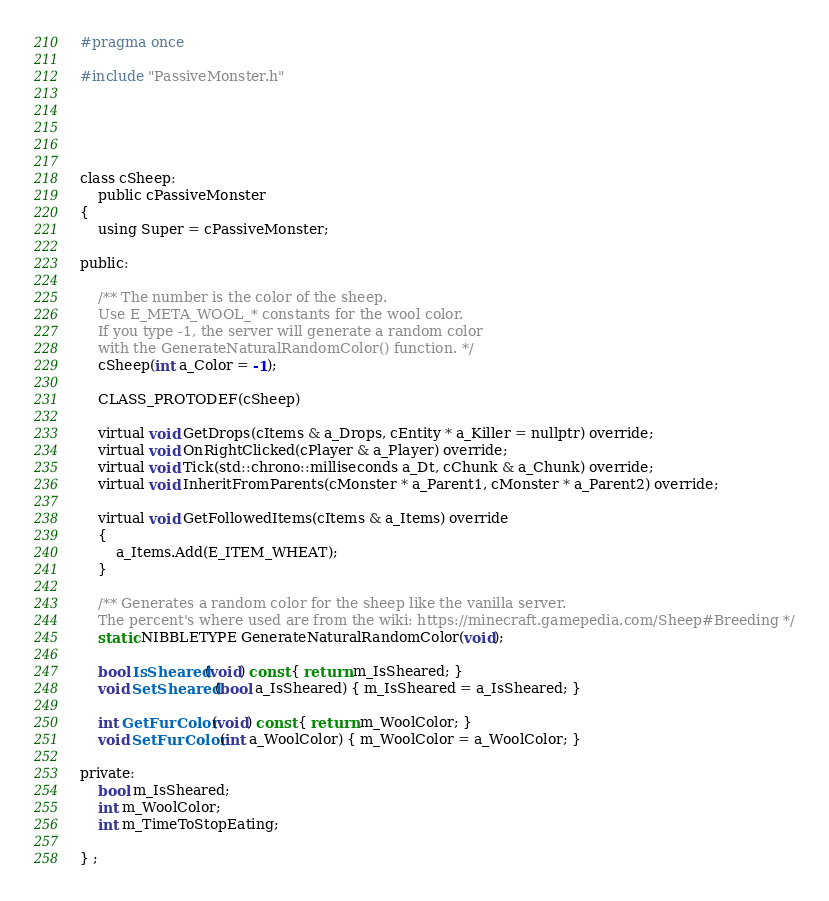Convert code to text. <code><loc_0><loc_0><loc_500><loc_500><_C_>
#pragma once

#include "PassiveMonster.h"





class cSheep:
	public cPassiveMonster
{
	using Super = cPassiveMonster;

public:

	/** The number is the color of the sheep.
	Use E_META_WOOL_* constants for the wool color.
	If you type -1, the server will generate a random color
	with the GenerateNaturalRandomColor() function. */
	cSheep(int a_Color = -1);

	CLASS_PROTODEF(cSheep)

	virtual void GetDrops(cItems & a_Drops, cEntity * a_Killer = nullptr) override;
	virtual void OnRightClicked(cPlayer & a_Player) override;
	virtual void Tick(std::chrono::milliseconds a_Dt, cChunk & a_Chunk) override;
	virtual void InheritFromParents(cMonster * a_Parent1, cMonster * a_Parent2) override;

	virtual void GetFollowedItems(cItems & a_Items) override
	{
		a_Items.Add(E_ITEM_WHEAT);
	}

	/** Generates a random color for the sheep like the vanilla server.
	The percent's where used are from the wiki: https://minecraft.gamepedia.com/Sheep#Breeding */
	static NIBBLETYPE GenerateNaturalRandomColor(void);

	bool IsSheared(void) const { return m_IsSheared; }
	void SetSheared(bool a_IsSheared) { m_IsSheared = a_IsSheared; }

	int GetFurColor(void) const { return m_WoolColor; }
	void SetFurColor(int a_WoolColor) { m_WoolColor = a_WoolColor; }

private:
	bool m_IsSheared;
	int m_WoolColor;
	int m_TimeToStopEating;

} ;




</code> 